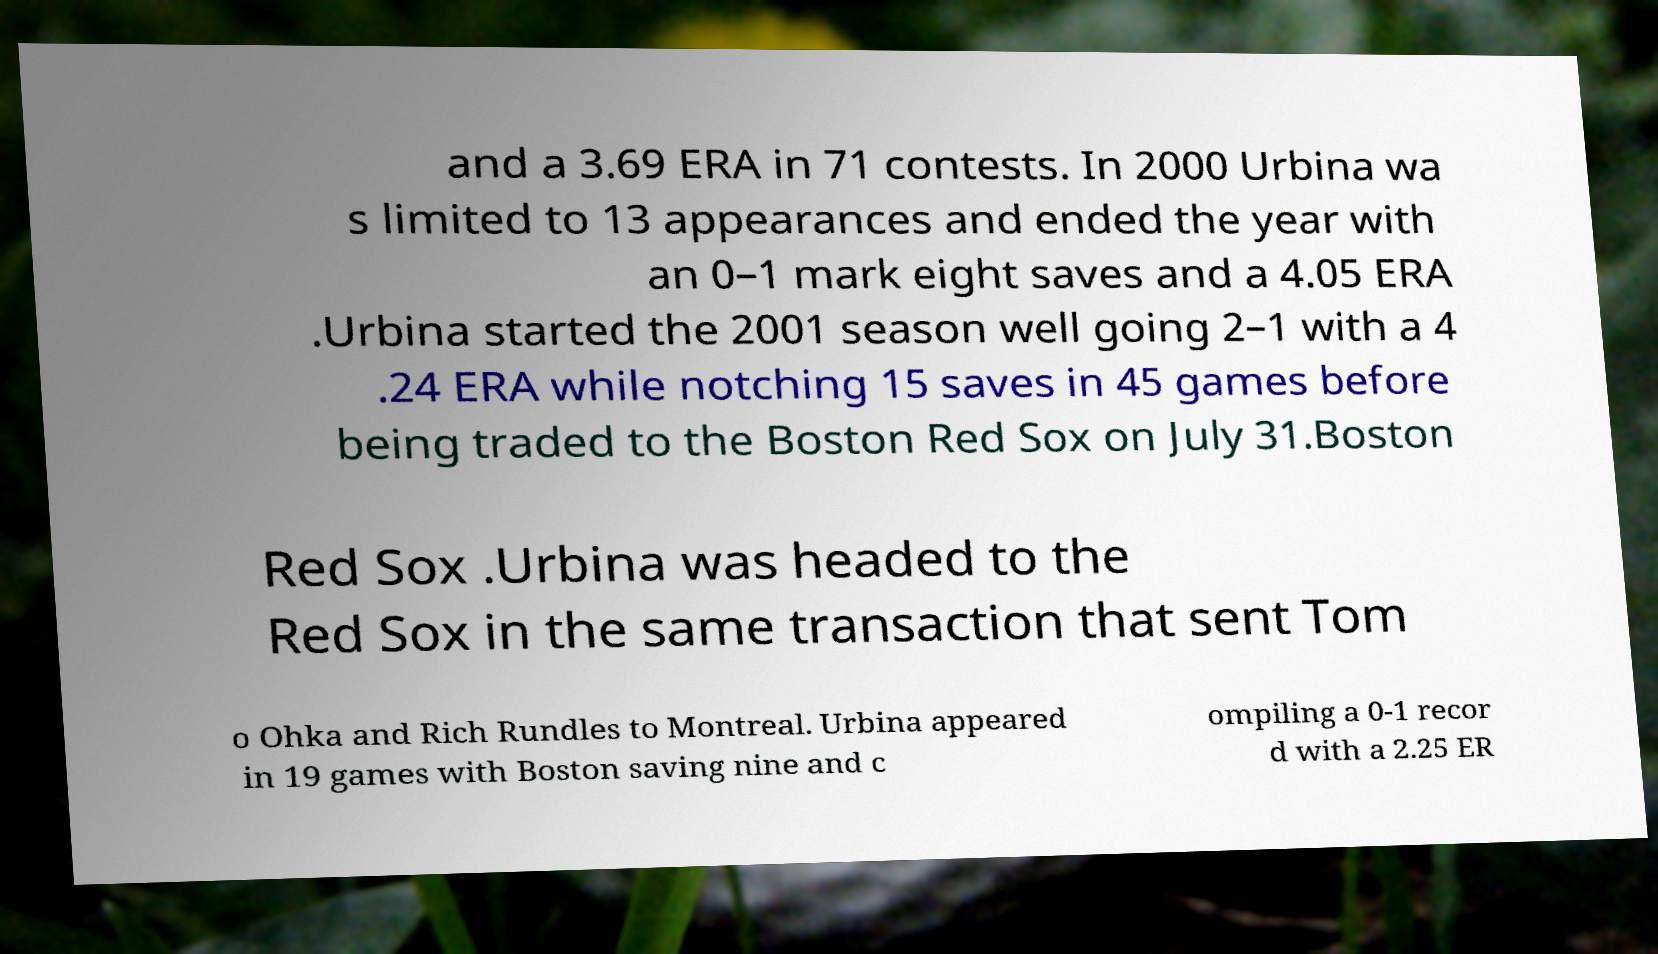Can you accurately transcribe the text from the provided image for me? and a 3.69 ERA in 71 contests. In 2000 Urbina wa s limited to 13 appearances and ended the year with an 0–1 mark eight saves and a 4.05 ERA .Urbina started the 2001 season well going 2–1 with a 4 .24 ERA while notching 15 saves in 45 games before being traded to the Boston Red Sox on July 31.Boston Red Sox .Urbina was headed to the Red Sox in the same transaction that sent Tom o Ohka and Rich Rundles to Montreal. Urbina appeared in 19 games with Boston saving nine and c ompiling a 0-1 recor d with a 2.25 ER 